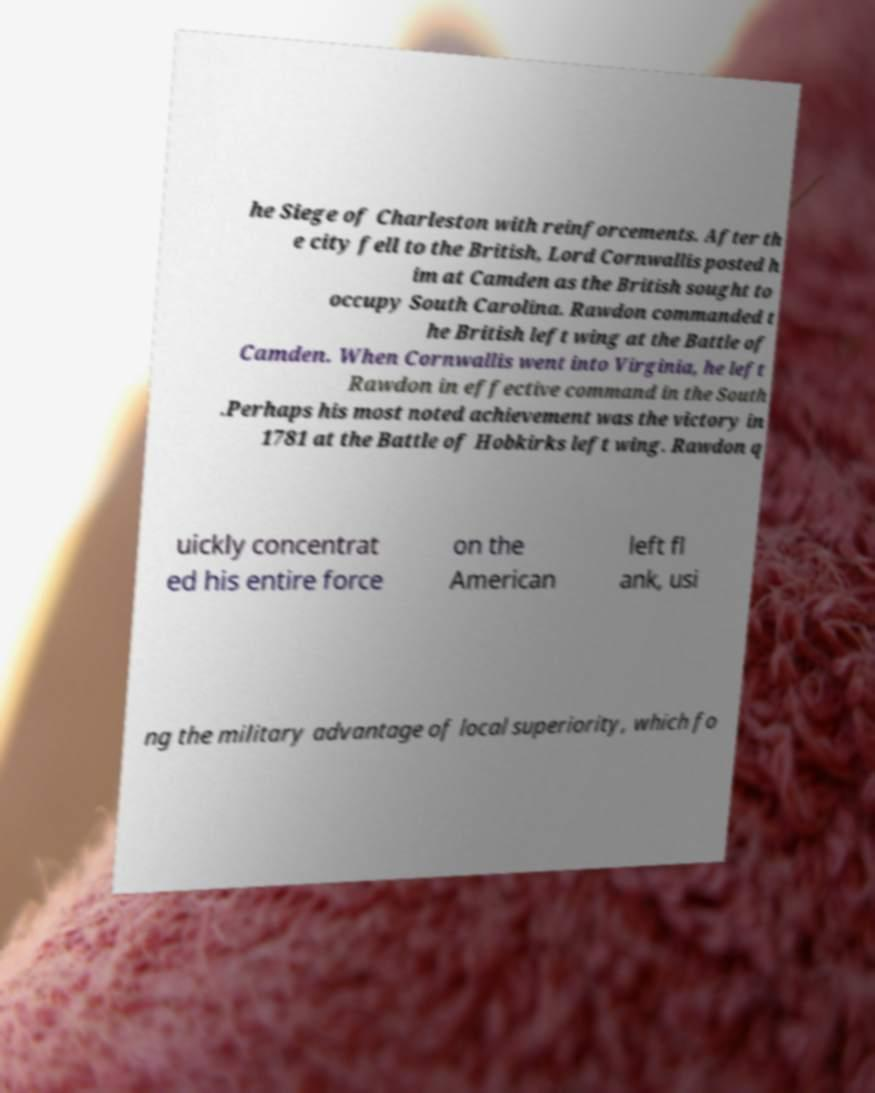Please identify and transcribe the text found in this image. he Siege of Charleston with reinforcements. After th e city fell to the British, Lord Cornwallis posted h im at Camden as the British sought to occupy South Carolina. Rawdon commanded t he British left wing at the Battle of Camden. When Cornwallis went into Virginia, he left Rawdon in effective command in the South .Perhaps his most noted achievement was the victory in 1781 at the Battle of Hobkirks left wing. Rawdon q uickly concentrat ed his entire force on the American left fl ank, usi ng the military advantage of local superiority, which fo 